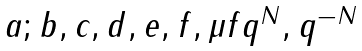<formula> <loc_0><loc_0><loc_500><loc_500>\begin{matrix} a ; b , c , d , e , f , \mu f q ^ { N } , q ^ { - N } \end{matrix}</formula> 